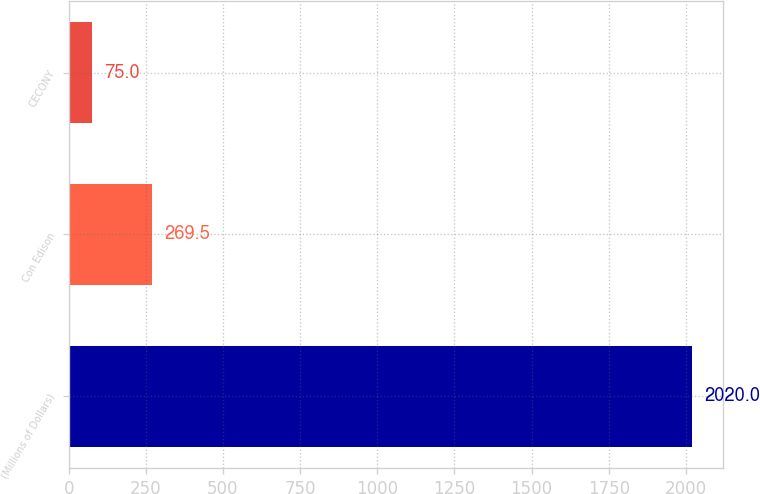<chart> <loc_0><loc_0><loc_500><loc_500><bar_chart><fcel>(Millions of Dollars)<fcel>Con Edison<fcel>CECONY<nl><fcel>2020<fcel>269.5<fcel>75<nl></chart> 